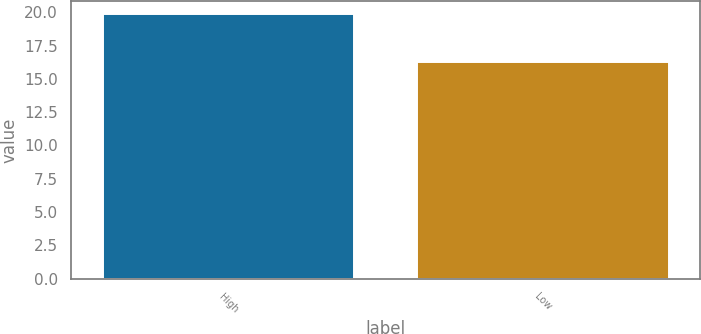Convert chart. <chart><loc_0><loc_0><loc_500><loc_500><bar_chart><fcel>High<fcel>Low<nl><fcel>19.85<fcel>16.27<nl></chart> 